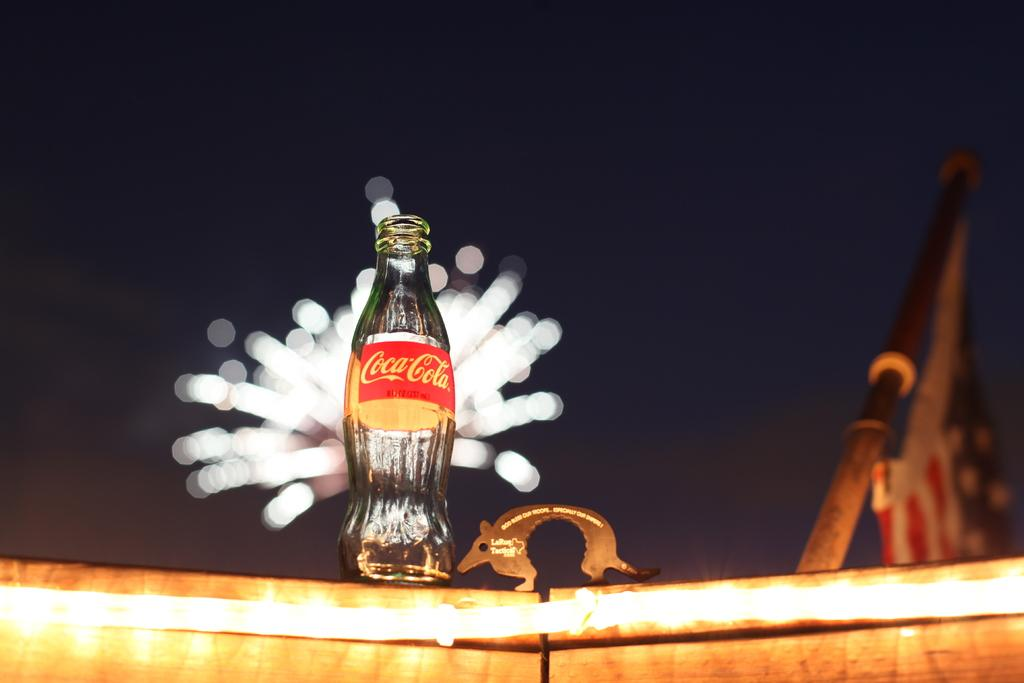<image>
Relay a brief, clear account of the picture shown. An empty glass bottle of Coca-Cola in front of fireworks 